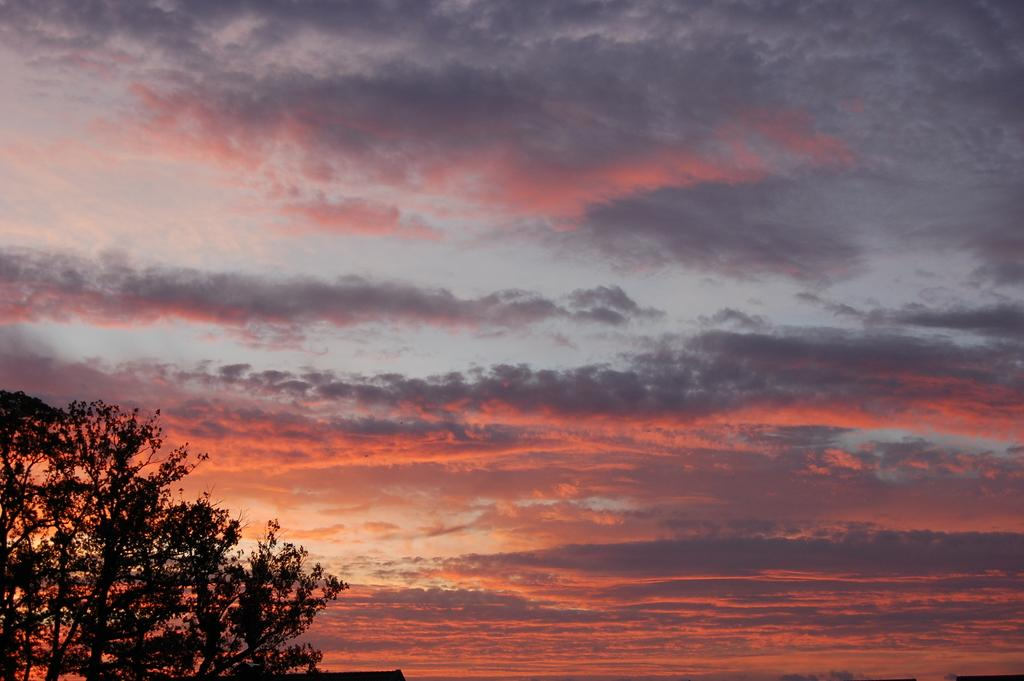What type of vegetation can be seen in the image? There are trees in the image. How would you describe the colors of the sky in the background? The sky in the background has white, gray, and orange colors. What type of potato is being smashed in the aftermath of the event in the image? There is no potato or event present in the image; it only features trees and a sky with white, gray, and orange colors. 